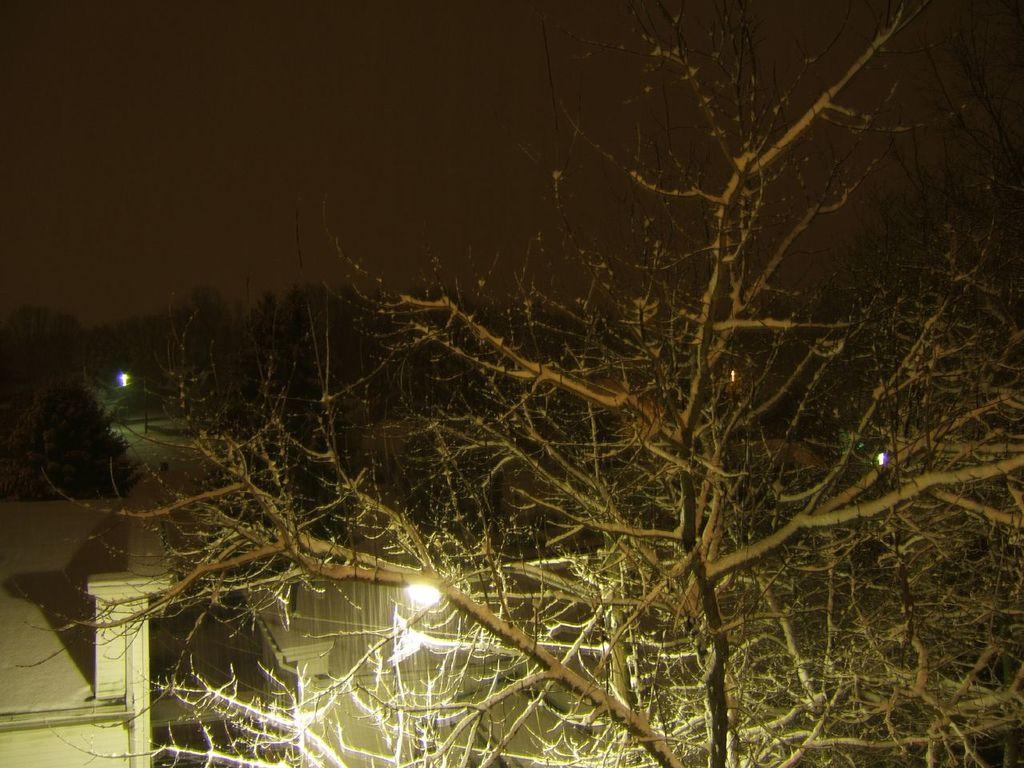Describe this image in one or two sentences. In the foreground of the picture there is a tree. In the center of the picture there are trees, street lights and buildings. At the top it is dark. 